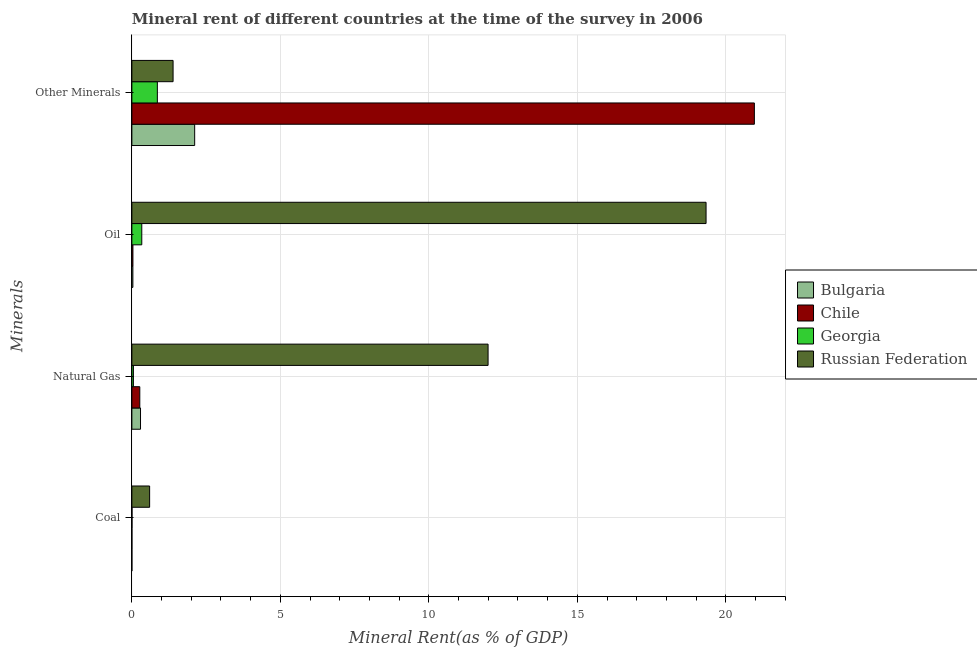How many different coloured bars are there?
Your answer should be very brief. 4. How many groups of bars are there?
Offer a terse response. 4. Are the number of bars per tick equal to the number of legend labels?
Provide a short and direct response. Yes. How many bars are there on the 2nd tick from the top?
Offer a very short reply. 4. What is the label of the 1st group of bars from the top?
Make the answer very short. Other Minerals. What is the coal rent in Georgia?
Keep it short and to the point. 0. Across all countries, what is the maximum oil rent?
Give a very brief answer. 19.33. Across all countries, what is the minimum coal rent?
Ensure brevity in your answer.  0. In which country was the oil rent maximum?
Your answer should be very brief. Russian Federation. In which country was the natural gas rent minimum?
Offer a very short reply. Georgia. What is the total oil rent in the graph?
Keep it short and to the point. 19.74. What is the difference between the coal rent in Georgia and that in Chile?
Offer a very short reply. 0. What is the difference between the coal rent in Georgia and the oil rent in Chile?
Provide a succinct answer. -0.03. What is the average natural gas rent per country?
Keep it short and to the point. 3.15. What is the difference between the coal rent and oil rent in Georgia?
Make the answer very short. -0.33. What is the ratio of the natural gas rent in Georgia to that in Russian Federation?
Make the answer very short. 0. What is the difference between the highest and the second highest  rent of other minerals?
Provide a short and direct response. 18.85. What is the difference between the highest and the lowest oil rent?
Offer a terse response. 19.3. In how many countries, is the natural gas rent greater than the average natural gas rent taken over all countries?
Your answer should be very brief. 1. Is the sum of the  rent of other minerals in Chile and Russian Federation greater than the maximum coal rent across all countries?
Give a very brief answer. Yes. What does the 4th bar from the bottom in Coal represents?
Ensure brevity in your answer.  Russian Federation. Is it the case that in every country, the sum of the coal rent and natural gas rent is greater than the oil rent?
Keep it short and to the point. No. Are all the bars in the graph horizontal?
Make the answer very short. Yes. How many countries are there in the graph?
Your answer should be compact. 4. What is the difference between two consecutive major ticks on the X-axis?
Provide a short and direct response. 5. How many legend labels are there?
Keep it short and to the point. 4. How are the legend labels stacked?
Offer a very short reply. Vertical. What is the title of the graph?
Provide a short and direct response. Mineral rent of different countries at the time of the survey in 2006. What is the label or title of the X-axis?
Your answer should be very brief. Mineral Rent(as % of GDP). What is the label or title of the Y-axis?
Offer a terse response. Minerals. What is the Mineral Rent(as % of GDP) of Bulgaria in Coal?
Offer a terse response. 0. What is the Mineral Rent(as % of GDP) of Chile in Coal?
Your answer should be compact. 0. What is the Mineral Rent(as % of GDP) in Georgia in Coal?
Give a very brief answer. 0. What is the Mineral Rent(as % of GDP) of Russian Federation in Coal?
Offer a very short reply. 0.6. What is the Mineral Rent(as % of GDP) in Bulgaria in Natural Gas?
Your response must be concise. 0.29. What is the Mineral Rent(as % of GDP) of Chile in Natural Gas?
Give a very brief answer. 0.27. What is the Mineral Rent(as % of GDP) of Georgia in Natural Gas?
Make the answer very short. 0.05. What is the Mineral Rent(as % of GDP) of Russian Federation in Natural Gas?
Ensure brevity in your answer.  11.99. What is the Mineral Rent(as % of GDP) in Bulgaria in Oil?
Provide a succinct answer. 0.03. What is the Mineral Rent(as % of GDP) in Chile in Oil?
Provide a succinct answer. 0.04. What is the Mineral Rent(as % of GDP) of Georgia in Oil?
Keep it short and to the point. 0.33. What is the Mineral Rent(as % of GDP) of Russian Federation in Oil?
Keep it short and to the point. 19.33. What is the Mineral Rent(as % of GDP) of Bulgaria in Other Minerals?
Ensure brevity in your answer.  2.11. What is the Mineral Rent(as % of GDP) of Chile in Other Minerals?
Provide a short and direct response. 20.96. What is the Mineral Rent(as % of GDP) of Georgia in Other Minerals?
Your answer should be compact. 0.86. What is the Mineral Rent(as % of GDP) of Russian Federation in Other Minerals?
Offer a very short reply. 1.39. Across all Minerals, what is the maximum Mineral Rent(as % of GDP) in Bulgaria?
Provide a short and direct response. 2.11. Across all Minerals, what is the maximum Mineral Rent(as % of GDP) in Chile?
Provide a succinct answer. 20.96. Across all Minerals, what is the maximum Mineral Rent(as % of GDP) in Georgia?
Keep it short and to the point. 0.86. Across all Minerals, what is the maximum Mineral Rent(as % of GDP) in Russian Federation?
Your response must be concise. 19.33. Across all Minerals, what is the minimum Mineral Rent(as % of GDP) in Bulgaria?
Make the answer very short. 0. Across all Minerals, what is the minimum Mineral Rent(as % of GDP) in Chile?
Provide a succinct answer. 0. Across all Minerals, what is the minimum Mineral Rent(as % of GDP) of Georgia?
Provide a succinct answer. 0. Across all Minerals, what is the minimum Mineral Rent(as % of GDP) of Russian Federation?
Provide a short and direct response. 0.6. What is the total Mineral Rent(as % of GDP) in Bulgaria in the graph?
Offer a terse response. 2.44. What is the total Mineral Rent(as % of GDP) in Chile in the graph?
Keep it short and to the point. 21.27. What is the total Mineral Rent(as % of GDP) in Georgia in the graph?
Keep it short and to the point. 1.25. What is the total Mineral Rent(as % of GDP) of Russian Federation in the graph?
Offer a terse response. 33.31. What is the difference between the Mineral Rent(as % of GDP) of Bulgaria in Coal and that in Natural Gas?
Offer a terse response. -0.29. What is the difference between the Mineral Rent(as % of GDP) of Chile in Coal and that in Natural Gas?
Your answer should be very brief. -0.27. What is the difference between the Mineral Rent(as % of GDP) of Georgia in Coal and that in Natural Gas?
Provide a succinct answer. -0.05. What is the difference between the Mineral Rent(as % of GDP) in Russian Federation in Coal and that in Natural Gas?
Make the answer very short. -11.4. What is the difference between the Mineral Rent(as % of GDP) of Bulgaria in Coal and that in Oil?
Keep it short and to the point. -0.03. What is the difference between the Mineral Rent(as % of GDP) in Chile in Coal and that in Oil?
Give a very brief answer. -0.03. What is the difference between the Mineral Rent(as % of GDP) in Georgia in Coal and that in Oil?
Your answer should be compact. -0.33. What is the difference between the Mineral Rent(as % of GDP) of Russian Federation in Coal and that in Oil?
Give a very brief answer. -18.74. What is the difference between the Mineral Rent(as % of GDP) in Bulgaria in Coal and that in Other Minerals?
Offer a very short reply. -2.11. What is the difference between the Mineral Rent(as % of GDP) in Chile in Coal and that in Other Minerals?
Provide a succinct answer. -20.96. What is the difference between the Mineral Rent(as % of GDP) of Georgia in Coal and that in Other Minerals?
Ensure brevity in your answer.  -0.85. What is the difference between the Mineral Rent(as % of GDP) of Russian Federation in Coal and that in Other Minerals?
Offer a terse response. -0.79. What is the difference between the Mineral Rent(as % of GDP) of Bulgaria in Natural Gas and that in Oil?
Keep it short and to the point. 0.26. What is the difference between the Mineral Rent(as % of GDP) of Chile in Natural Gas and that in Oil?
Make the answer very short. 0.23. What is the difference between the Mineral Rent(as % of GDP) of Georgia in Natural Gas and that in Oil?
Ensure brevity in your answer.  -0.28. What is the difference between the Mineral Rent(as % of GDP) of Russian Federation in Natural Gas and that in Oil?
Provide a succinct answer. -7.34. What is the difference between the Mineral Rent(as % of GDP) in Bulgaria in Natural Gas and that in Other Minerals?
Offer a terse response. -1.82. What is the difference between the Mineral Rent(as % of GDP) in Chile in Natural Gas and that in Other Minerals?
Provide a succinct answer. -20.7. What is the difference between the Mineral Rent(as % of GDP) of Georgia in Natural Gas and that in Other Minerals?
Give a very brief answer. -0.81. What is the difference between the Mineral Rent(as % of GDP) in Russian Federation in Natural Gas and that in Other Minerals?
Your answer should be very brief. 10.61. What is the difference between the Mineral Rent(as % of GDP) of Bulgaria in Oil and that in Other Minerals?
Give a very brief answer. -2.08. What is the difference between the Mineral Rent(as % of GDP) in Chile in Oil and that in Other Minerals?
Keep it short and to the point. -20.93. What is the difference between the Mineral Rent(as % of GDP) of Georgia in Oil and that in Other Minerals?
Your answer should be very brief. -0.52. What is the difference between the Mineral Rent(as % of GDP) in Russian Federation in Oil and that in Other Minerals?
Offer a terse response. 17.95. What is the difference between the Mineral Rent(as % of GDP) of Bulgaria in Coal and the Mineral Rent(as % of GDP) of Chile in Natural Gas?
Offer a terse response. -0.27. What is the difference between the Mineral Rent(as % of GDP) of Bulgaria in Coal and the Mineral Rent(as % of GDP) of Georgia in Natural Gas?
Provide a short and direct response. -0.05. What is the difference between the Mineral Rent(as % of GDP) in Bulgaria in Coal and the Mineral Rent(as % of GDP) in Russian Federation in Natural Gas?
Offer a terse response. -11.99. What is the difference between the Mineral Rent(as % of GDP) in Chile in Coal and the Mineral Rent(as % of GDP) in Georgia in Natural Gas?
Offer a very short reply. -0.05. What is the difference between the Mineral Rent(as % of GDP) in Chile in Coal and the Mineral Rent(as % of GDP) in Russian Federation in Natural Gas?
Offer a terse response. -11.99. What is the difference between the Mineral Rent(as % of GDP) of Georgia in Coal and the Mineral Rent(as % of GDP) of Russian Federation in Natural Gas?
Offer a terse response. -11.99. What is the difference between the Mineral Rent(as % of GDP) of Bulgaria in Coal and the Mineral Rent(as % of GDP) of Chile in Oil?
Your answer should be very brief. -0.04. What is the difference between the Mineral Rent(as % of GDP) in Bulgaria in Coal and the Mineral Rent(as % of GDP) in Russian Federation in Oil?
Offer a terse response. -19.33. What is the difference between the Mineral Rent(as % of GDP) in Chile in Coal and the Mineral Rent(as % of GDP) in Georgia in Oil?
Provide a short and direct response. -0.33. What is the difference between the Mineral Rent(as % of GDP) in Chile in Coal and the Mineral Rent(as % of GDP) in Russian Federation in Oil?
Your answer should be very brief. -19.33. What is the difference between the Mineral Rent(as % of GDP) in Georgia in Coal and the Mineral Rent(as % of GDP) in Russian Federation in Oil?
Provide a succinct answer. -19.33. What is the difference between the Mineral Rent(as % of GDP) in Bulgaria in Coal and the Mineral Rent(as % of GDP) in Chile in Other Minerals?
Your answer should be compact. -20.96. What is the difference between the Mineral Rent(as % of GDP) in Bulgaria in Coal and the Mineral Rent(as % of GDP) in Georgia in Other Minerals?
Provide a succinct answer. -0.86. What is the difference between the Mineral Rent(as % of GDP) in Bulgaria in Coal and the Mineral Rent(as % of GDP) in Russian Federation in Other Minerals?
Give a very brief answer. -1.39. What is the difference between the Mineral Rent(as % of GDP) of Chile in Coal and the Mineral Rent(as % of GDP) of Georgia in Other Minerals?
Offer a very short reply. -0.86. What is the difference between the Mineral Rent(as % of GDP) of Chile in Coal and the Mineral Rent(as % of GDP) of Russian Federation in Other Minerals?
Offer a very short reply. -1.39. What is the difference between the Mineral Rent(as % of GDP) of Georgia in Coal and the Mineral Rent(as % of GDP) of Russian Federation in Other Minerals?
Keep it short and to the point. -1.38. What is the difference between the Mineral Rent(as % of GDP) of Bulgaria in Natural Gas and the Mineral Rent(as % of GDP) of Chile in Oil?
Keep it short and to the point. 0.26. What is the difference between the Mineral Rent(as % of GDP) of Bulgaria in Natural Gas and the Mineral Rent(as % of GDP) of Georgia in Oil?
Ensure brevity in your answer.  -0.04. What is the difference between the Mineral Rent(as % of GDP) in Bulgaria in Natural Gas and the Mineral Rent(as % of GDP) in Russian Federation in Oil?
Give a very brief answer. -19.04. What is the difference between the Mineral Rent(as % of GDP) in Chile in Natural Gas and the Mineral Rent(as % of GDP) in Georgia in Oil?
Provide a succinct answer. -0.07. What is the difference between the Mineral Rent(as % of GDP) in Chile in Natural Gas and the Mineral Rent(as % of GDP) in Russian Federation in Oil?
Keep it short and to the point. -19.07. What is the difference between the Mineral Rent(as % of GDP) in Georgia in Natural Gas and the Mineral Rent(as % of GDP) in Russian Federation in Oil?
Keep it short and to the point. -19.28. What is the difference between the Mineral Rent(as % of GDP) in Bulgaria in Natural Gas and the Mineral Rent(as % of GDP) in Chile in Other Minerals?
Provide a succinct answer. -20.67. What is the difference between the Mineral Rent(as % of GDP) in Bulgaria in Natural Gas and the Mineral Rent(as % of GDP) in Georgia in Other Minerals?
Keep it short and to the point. -0.57. What is the difference between the Mineral Rent(as % of GDP) in Bulgaria in Natural Gas and the Mineral Rent(as % of GDP) in Russian Federation in Other Minerals?
Ensure brevity in your answer.  -1.1. What is the difference between the Mineral Rent(as % of GDP) in Chile in Natural Gas and the Mineral Rent(as % of GDP) in Georgia in Other Minerals?
Offer a terse response. -0.59. What is the difference between the Mineral Rent(as % of GDP) in Chile in Natural Gas and the Mineral Rent(as % of GDP) in Russian Federation in Other Minerals?
Offer a very short reply. -1.12. What is the difference between the Mineral Rent(as % of GDP) in Georgia in Natural Gas and the Mineral Rent(as % of GDP) in Russian Federation in Other Minerals?
Offer a very short reply. -1.34. What is the difference between the Mineral Rent(as % of GDP) of Bulgaria in Oil and the Mineral Rent(as % of GDP) of Chile in Other Minerals?
Your response must be concise. -20.93. What is the difference between the Mineral Rent(as % of GDP) in Bulgaria in Oil and the Mineral Rent(as % of GDP) in Georgia in Other Minerals?
Keep it short and to the point. -0.82. What is the difference between the Mineral Rent(as % of GDP) of Bulgaria in Oil and the Mineral Rent(as % of GDP) of Russian Federation in Other Minerals?
Keep it short and to the point. -1.35. What is the difference between the Mineral Rent(as % of GDP) of Chile in Oil and the Mineral Rent(as % of GDP) of Georgia in Other Minerals?
Ensure brevity in your answer.  -0.82. What is the difference between the Mineral Rent(as % of GDP) in Chile in Oil and the Mineral Rent(as % of GDP) in Russian Federation in Other Minerals?
Give a very brief answer. -1.35. What is the difference between the Mineral Rent(as % of GDP) of Georgia in Oil and the Mineral Rent(as % of GDP) of Russian Federation in Other Minerals?
Offer a very short reply. -1.05. What is the average Mineral Rent(as % of GDP) of Bulgaria per Minerals?
Your answer should be very brief. 0.61. What is the average Mineral Rent(as % of GDP) of Chile per Minerals?
Ensure brevity in your answer.  5.32. What is the average Mineral Rent(as % of GDP) in Georgia per Minerals?
Make the answer very short. 0.31. What is the average Mineral Rent(as % of GDP) of Russian Federation per Minerals?
Give a very brief answer. 8.33. What is the difference between the Mineral Rent(as % of GDP) in Bulgaria and Mineral Rent(as % of GDP) in Chile in Coal?
Keep it short and to the point. -0. What is the difference between the Mineral Rent(as % of GDP) of Bulgaria and Mineral Rent(as % of GDP) of Georgia in Coal?
Offer a very short reply. -0. What is the difference between the Mineral Rent(as % of GDP) in Bulgaria and Mineral Rent(as % of GDP) in Russian Federation in Coal?
Keep it short and to the point. -0.6. What is the difference between the Mineral Rent(as % of GDP) in Chile and Mineral Rent(as % of GDP) in Georgia in Coal?
Your answer should be very brief. -0. What is the difference between the Mineral Rent(as % of GDP) of Chile and Mineral Rent(as % of GDP) of Russian Federation in Coal?
Offer a very short reply. -0.6. What is the difference between the Mineral Rent(as % of GDP) in Georgia and Mineral Rent(as % of GDP) in Russian Federation in Coal?
Give a very brief answer. -0.59. What is the difference between the Mineral Rent(as % of GDP) of Bulgaria and Mineral Rent(as % of GDP) of Chile in Natural Gas?
Ensure brevity in your answer.  0.02. What is the difference between the Mineral Rent(as % of GDP) of Bulgaria and Mineral Rent(as % of GDP) of Georgia in Natural Gas?
Offer a terse response. 0.24. What is the difference between the Mineral Rent(as % of GDP) of Bulgaria and Mineral Rent(as % of GDP) of Russian Federation in Natural Gas?
Ensure brevity in your answer.  -11.7. What is the difference between the Mineral Rent(as % of GDP) in Chile and Mineral Rent(as % of GDP) in Georgia in Natural Gas?
Offer a very short reply. 0.22. What is the difference between the Mineral Rent(as % of GDP) in Chile and Mineral Rent(as % of GDP) in Russian Federation in Natural Gas?
Your answer should be very brief. -11.73. What is the difference between the Mineral Rent(as % of GDP) in Georgia and Mineral Rent(as % of GDP) in Russian Federation in Natural Gas?
Your response must be concise. -11.94. What is the difference between the Mineral Rent(as % of GDP) of Bulgaria and Mineral Rent(as % of GDP) of Chile in Oil?
Offer a terse response. -0. What is the difference between the Mineral Rent(as % of GDP) of Bulgaria and Mineral Rent(as % of GDP) of Georgia in Oil?
Make the answer very short. -0.3. What is the difference between the Mineral Rent(as % of GDP) in Bulgaria and Mineral Rent(as % of GDP) in Russian Federation in Oil?
Keep it short and to the point. -19.3. What is the difference between the Mineral Rent(as % of GDP) in Chile and Mineral Rent(as % of GDP) in Georgia in Oil?
Provide a short and direct response. -0.3. What is the difference between the Mineral Rent(as % of GDP) of Chile and Mineral Rent(as % of GDP) of Russian Federation in Oil?
Your answer should be compact. -19.3. What is the difference between the Mineral Rent(as % of GDP) of Georgia and Mineral Rent(as % of GDP) of Russian Federation in Oil?
Offer a very short reply. -19. What is the difference between the Mineral Rent(as % of GDP) in Bulgaria and Mineral Rent(as % of GDP) in Chile in Other Minerals?
Provide a short and direct response. -18.85. What is the difference between the Mineral Rent(as % of GDP) in Bulgaria and Mineral Rent(as % of GDP) in Georgia in Other Minerals?
Keep it short and to the point. 1.26. What is the difference between the Mineral Rent(as % of GDP) in Bulgaria and Mineral Rent(as % of GDP) in Russian Federation in Other Minerals?
Your answer should be very brief. 0.73. What is the difference between the Mineral Rent(as % of GDP) of Chile and Mineral Rent(as % of GDP) of Georgia in Other Minerals?
Provide a short and direct response. 20.1. What is the difference between the Mineral Rent(as % of GDP) in Chile and Mineral Rent(as % of GDP) in Russian Federation in Other Minerals?
Provide a short and direct response. 19.57. What is the difference between the Mineral Rent(as % of GDP) of Georgia and Mineral Rent(as % of GDP) of Russian Federation in Other Minerals?
Your response must be concise. -0.53. What is the ratio of the Mineral Rent(as % of GDP) in Chile in Coal to that in Natural Gas?
Your answer should be compact. 0. What is the ratio of the Mineral Rent(as % of GDP) of Georgia in Coal to that in Natural Gas?
Your response must be concise. 0.08. What is the ratio of the Mineral Rent(as % of GDP) in Russian Federation in Coal to that in Natural Gas?
Your answer should be very brief. 0.05. What is the ratio of the Mineral Rent(as % of GDP) of Bulgaria in Coal to that in Oil?
Offer a terse response. 0.01. What is the ratio of the Mineral Rent(as % of GDP) of Chile in Coal to that in Oil?
Give a very brief answer. 0.03. What is the ratio of the Mineral Rent(as % of GDP) in Georgia in Coal to that in Oil?
Your response must be concise. 0.01. What is the ratio of the Mineral Rent(as % of GDP) in Russian Federation in Coal to that in Oil?
Your answer should be compact. 0.03. What is the ratio of the Mineral Rent(as % of GDP) in Bulgaria in Coal to that in Other Minerals?
Ensure brevity in your answer.  0. What is the ratio of the Mineral Rent(as % of GDP) in Chile in Coal to that in Other Minerals?
Offer a very short reply. 0. What is the ratio of the Mineral Rent(as % of GDP) in Georgia in Coal to that in Other Minerals?
Your response must be concise. 0. What is the ratio of the Mineral Rent(as % of GDP) in Russian Federation in Coal to that in Other Minerals?
Provide a short and direct response. 0.43. What is the ratio of the Mineral Rent(as % of GDP) in Bulgaria in Natural Gas to that in Oil?
Make the answer very short. 8.62. What is the ratio of the Mineral Rent(as % of GDP) of Chile in Natural Gas to that in Oil?
Your response must be concise. 7.55. What is the ratio of the Mineral Rent(as % of GDP) of Georgia in Natural Gas to that in Oil?
Your answer should be very brief. 0.15. What is the ratio of the Mineral Rent(as % of GDP) of Russian Federation in Natural Gas to that in Oil?
Ensure brevity in your answer.  0.62. What is the ratio of the Mineral Rent(as % of GDP) in Bulgaria in Natural Gas to that in Other Minerals?
Make the answer very short. 0.14. What is the ratio of the Mineral Rent(as % of GDP) of Chile in Natural Gas to that in Other Minerals?
Make the answer very short. 0.01. What is the ratio of the Mineral Rent(as % of GDP) in Georgia in Natural Gas to that in Other Minerals?
Keep it short and to the point. 0.06. What is the ratio of the Mineral Rent(as % of GDP) in Russian Federation in Natural Gas to that in Other Minerals?
Your answer should be very brief. 8.64. What is the ratio of the Mineral Rent(as % of GDP) of Bulgaria in Oil to that in Other Minerals?
Offer a terse response. 0.02. What is the ratio of the Mineral Rent(as % of GDP) in Chile in Oil to that in Other Minerals?
Provide a succinct answer. 0. What is the ratio of the Mineral Rent(as % of GDP) of Georgia in Oil to that in Other Minerals?
Make the answer very short. 0.39. What is the ratio of the Mineral Rent(as % of GDP) in Russian Federation in Oil to that in Other Minerals?
Provide a succinct answer. 13.93. What is the difference between the highest and the second highest Mineral Rent(as % of GDP) of Bulgaria?
Ensure brevity in your answer.  1.82. What is the difference between the highest and the second highest Mineral Rent(as % of GDP) in Chile?
Offer a very short reply. 20.7. What is the difference between the highest and the second highest Mineral Rent(as % of GDP) of Georgia?
Provide a short and direct response. 0.52. What is the difference between the highest and the second highest Mineral Rent(as % of GDP) in Russian Federation?
Your answer should be very brief. 7.34. What is the difference between the highest and the lowest Mineral Rent(as % of GDP) in Bulgaria?
Provide a short and direct response. 2.11. What is the difference between the highest and the lowest Mineral Rent(as % of GDP) in Chile?
Provide a succinct answer. 20.96. What is the difference between the highest and the lowest Mineral Rent(as % of GDP) of Georgia?
Provide a succinct answer. 0.85. What is the difference between the highest and the lowest Mineral Rent(as % of GDP) of Russian Federation?
Give a very brief answer. 18.74. 